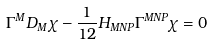Convert formula to latex. <formula><loc_0><loc_0><loc_500><loc_500>\Gamma ^ { M } D _ { M } \chi - \frac { 1 } { 1 2 } H _ { M N P } \Gamma ^ { M N P } \chi = 0</formula> 